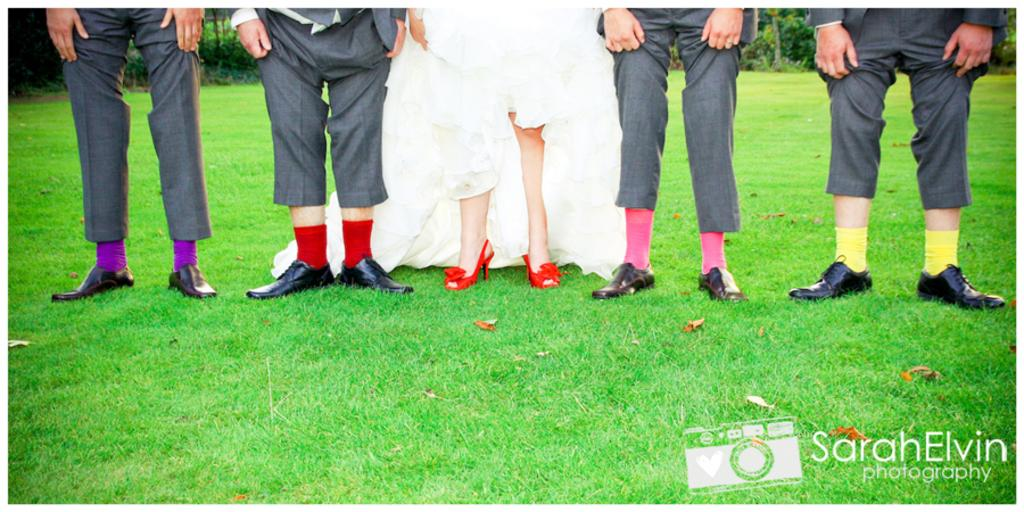What is in the foreground of the image? There are dry leaves and grass in the foreground of the image. What can be seen in the center of the image? There are people's legs in the center of the image. What is visible in the background of the image? There are plants and trees in the background of the image. Is there a scarecrow visible in the image? No, there is no scarecrow present in the image. How does the rainstorm affect the people's legs in the image? There is no rainstorm present in the image, so it cannot affect the people's legs. 